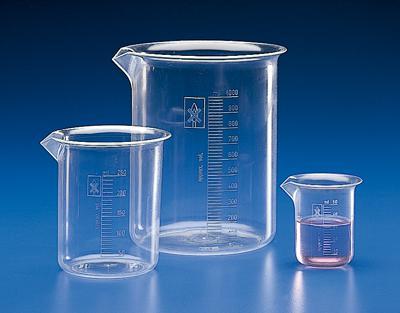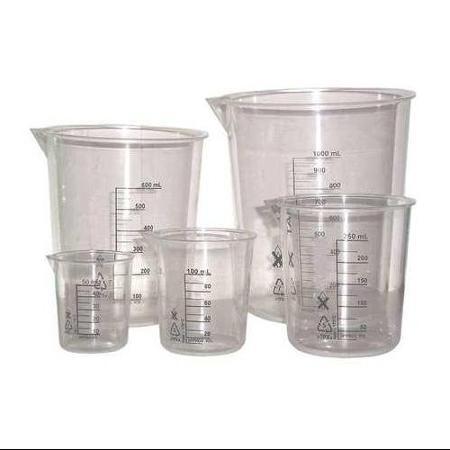The first image is the image on the left, the second image is the image on the right. Analyze the images presented: Is the assertion "there are clear beakers with a blue background" valid? Answer yes or no. Yes. 